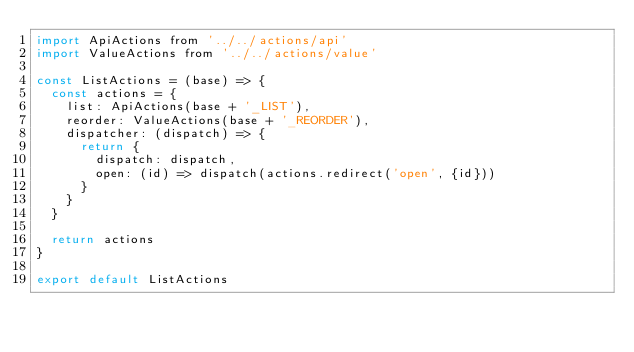Convert code to text. <code><loc_0><loc_0><loc_500><loc_500><_JavaScript_>import ApiActions from '../../actions/api'
import ValueActions from '../../actions/value'

const ListActions = (base) => {
  const actions = {
    list: ApiActions(base + '_LIST'),
    reorder: ValueActions(base + '_REORDER'),
    dispatcher: (dispatch) => {
      return {
        dispatch: dispatch,
        open: (id) => dispatch(actions.redirect('open', {id}))
      }
    }
  }

  return actions
}

export default ListActions
</code> 